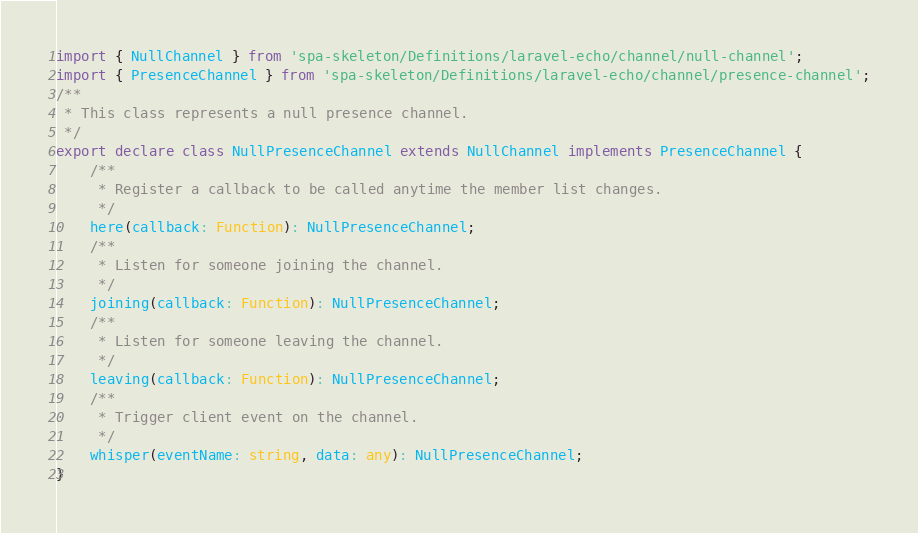<code> <loc_0><loc_0><loc_500><loc_500><_TypeScript_>import { NullChannel } from 'spa-skeleton/Definitions/laravel-echo/channel/null-channel';
import { PresenceChannel } from 'spa-skeleton/Definitions/laravel-echo/channel/presence-channel';
/**
 * This class represents a null presence channel.
 */
export declare class NullPresenceChannel extends NullChannel implements PresenceChannel {
    /**
     * Register a callback to be called anytime the member list changes.
     */
    here(callback: Function): NullPresenceChannel;
    /**
     * Listen for someone joining the channel.
     */
    joining(callback: Function): NullPresenceChannel;
    /**
     * Listen for someone leaving the channel.
     */
    leaving(callback: Function): NullPresenceChannel;
    /**
     * Trigger client event on the channel.
     */
    whisper(eventName: string, data: any): NullPresenceChannel;
}
</code> 